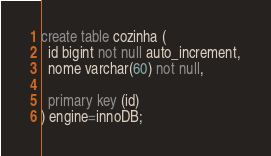<code> <loc_0><loc_0><loc_500><loc_500><_SQL_>create table cozinha (
  id bigint not null auto_increment,
  nome varchar(60) not null,
  
  primary key (id)
) engine=innoDB;</code> 